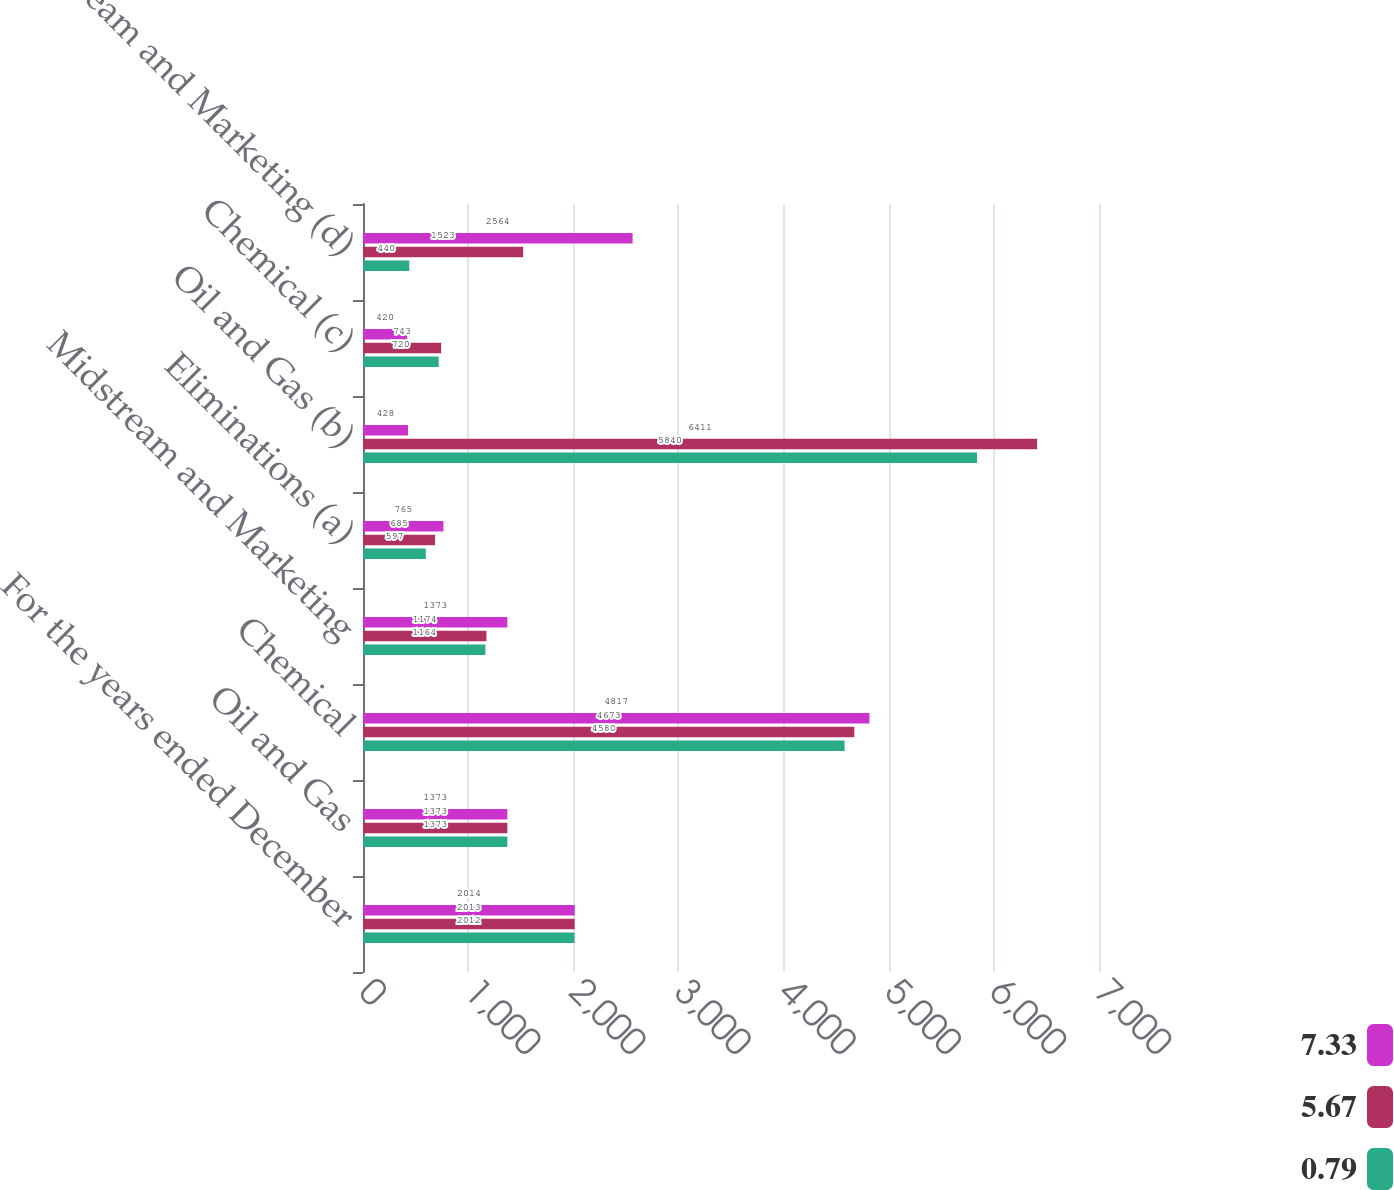Convert chart to OTSL. <chart><loc_0><loc_0><loc_500><loc_500><stacked_bar_chart><ecel><fcel>For the years ended December<fcel>Oil and Gas<fcel>Chemical<fcel>Midstream and Marketing<fcel>Eliminations (a)<fcel>Oil and Gas (b)<fcel>Chemical (c)<fcel>Midstream and Marketing (d)<nl><fcel>7.33<fcel>2014<fcel>1373<fcel>4817<fcel>1373<fcel>765<fcel>428<fcel>420<fcel>2564<nl><fcel>5.67<fcel>2013<fcel>1373<fcel>4673<fcel>1174<fcel>685<fcel>6411<fcel>743<fcel>1523<nl><fcel>0.79<fcel>2012<fcel>1373<fcel>4580<fcel>1164<fcel>597<fcel>5840<fcel>720<fcel>440<nl></chart> 